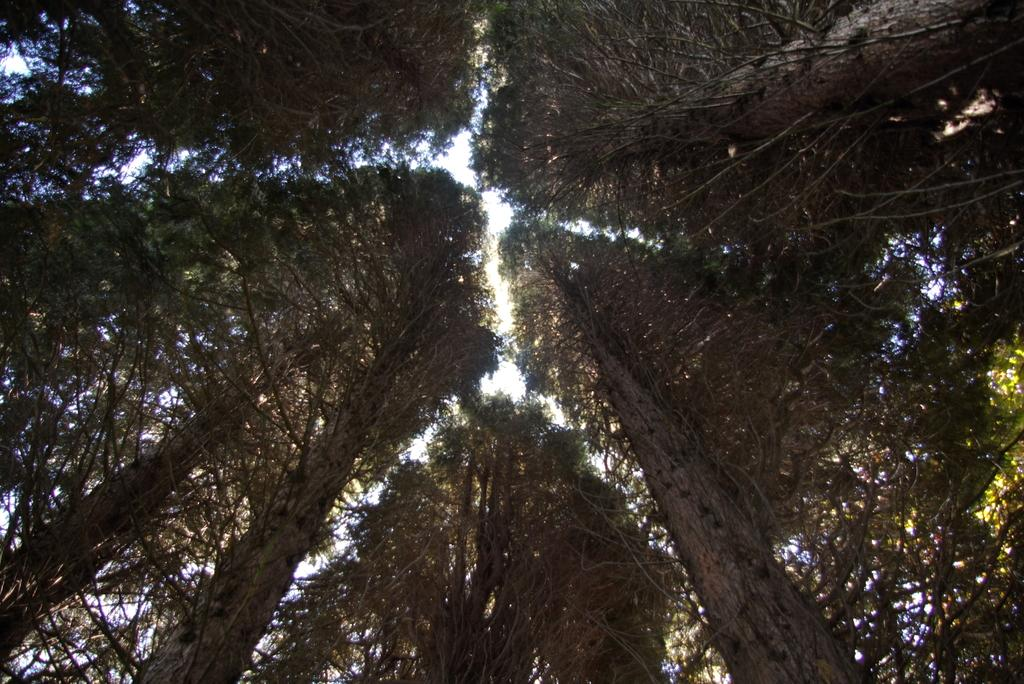What type of vegetation can be seen in the image? There are trees in the image. What colors are the trees in the image? The trees have green and brown colors. What can be seen in the background of the image? The sky is visible in the background through gaps between the trees. How many children are playing with soda cans in the image? There are no children or soda cans present in the image; it only features trees and the sky. 